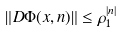<formula> <loc_0><loc_0><loc_500><loc_500>\| D \Phi ( x , n ) \| \leq \rho _ { 1 } ^ { | n | }</formula> 